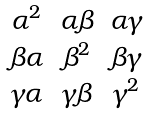<formula> <loc_0><loc_0><loc_500><loc_500>\begin{matrix} \alpha ^ { 2 } & \alpha \beta & \alpha \gamma \\ \beta \alpha & \beta ^ { 2 } & \beta \gamma \\ \gamma \alpha & \gamma \beta & \gamma ^ { 2 } \end{matrix}</formula> 